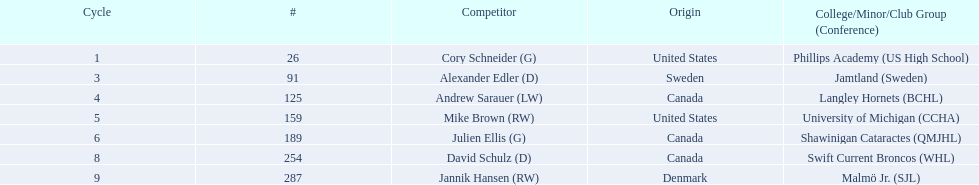Which players have canadian nationality? Andrew Sarauer (LW), Julien Ellis (G), David Schulz (D). Of those, which attended langley hornets? Andrew Sarauer (LW). Help me parse the entirety of this table. {'header': ['Cycle', '#', 'Competitor', 'Origin', 'College/Minor/Club Group (Conference)'], 'rows': [['1', '26', 'Cory Schneider (G)', 'United States', 'Phillips Academy (US High School)'], ['3', '91', 'Alexander Edler (D)', 'Sweden', 'Jamtland (Sweden)'], ['4', '125', 'Andrew Sarauer (LW)', 'Canada', 'Langley Hornets (BCHL)'], ['5', '159', 'Mike Brown (RW)', 'United States', 'University of Michigan (CCHA)'], ['6', '189', 'Julien Ellis (G)', 'Canada', 'Shawinigan Cataractes (QMJHL)'], ['8', '254', 'David Schulz (D)', 'Canada', 'Swift Current Broncos (WHL)'], ['9', '287', 'Jannik Hansen (RW)', 'Denmark', 'Malmö Jr. (SJL)']]} 